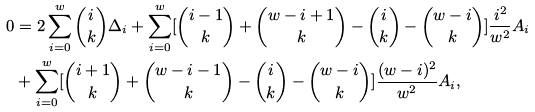Convert formula to latex. <formula><loc_0><loc_0><loc_500><loc_500>0 & = 2 \sum _ { i = 0 } ^ { w } \binom { i } { k } \Delta _ { i } + \sum _ { i = 0 } ^ { w } [ \binom { i - 1 } { k } + \binom { w - i + 1 } { k } - \binom { i } { k } - \binom { w - i } { k } ] \frac { i ^ { 2 } } { w ^ { 2 } } A _ { i } \\ & + \sum _ { i = 0 } ^ { w } [ \binom { i + 1 } { k } + \binom { w - i - 1 } { k } - \binom { i } { k } - \binom { w - i } { k } ] \frac { ( w - i ) ^ { 2 } } { w ^ { 2 } } A _ { i } ,</formula> 